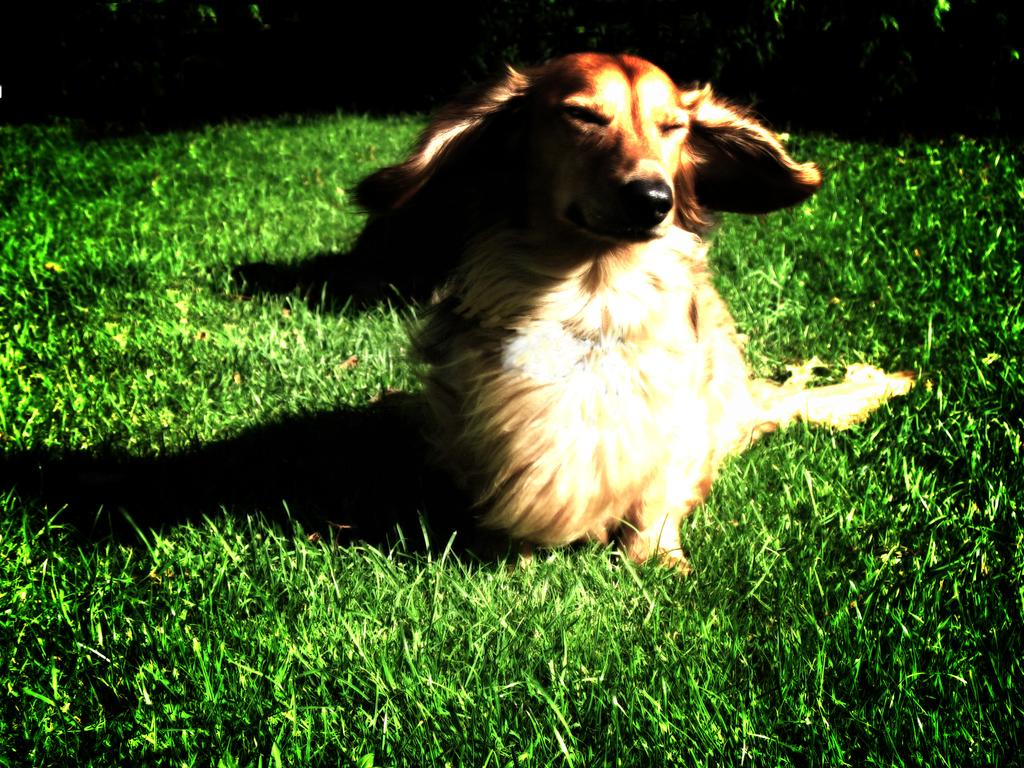What type of vegetation is present in the image? There is grass in the image. What animal can be seen in the image? There is a dog in the image. How would you describe the lighting in the image? The image is described as being a little dark. How many sisters does the dog have in the image? There are no sisters mentioned or depicted in the image, as it only features a dog and grass. Is the dog swimming in the image? There is no indication of the dog swimming in the image, as it is shown on grass. 